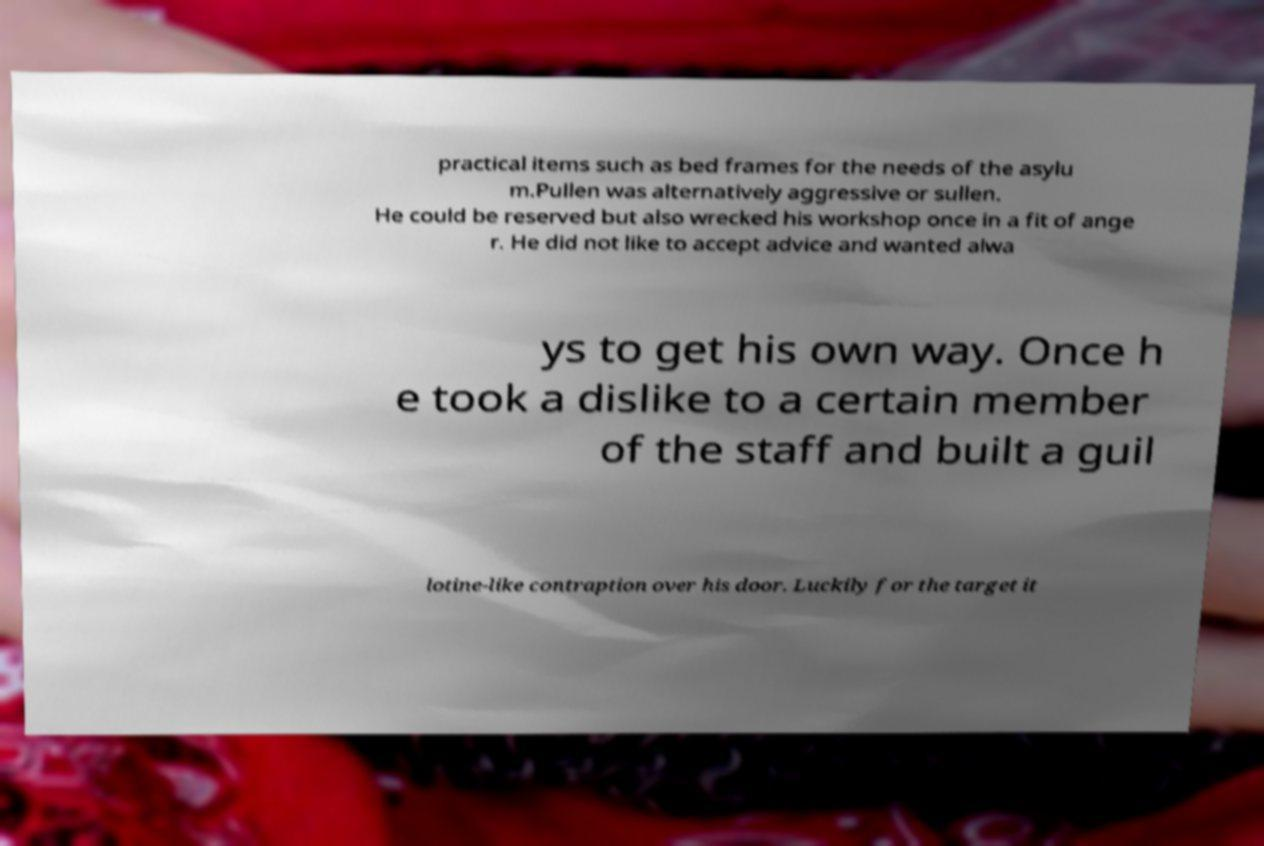Could you extract and type out the text from this image? practical items such as bed frames for the needs of the asylu m.Pullen was alternatively aggressive or sullen. He could be reserved but also wrecked his workshop once in a fit of ange r. He did not like to accept advice and wanted alwa ys to get his own way. Once h e took a dislike to a certain member of the staff and built a guil lotine-like contraption over his door. Luckily for the target it 